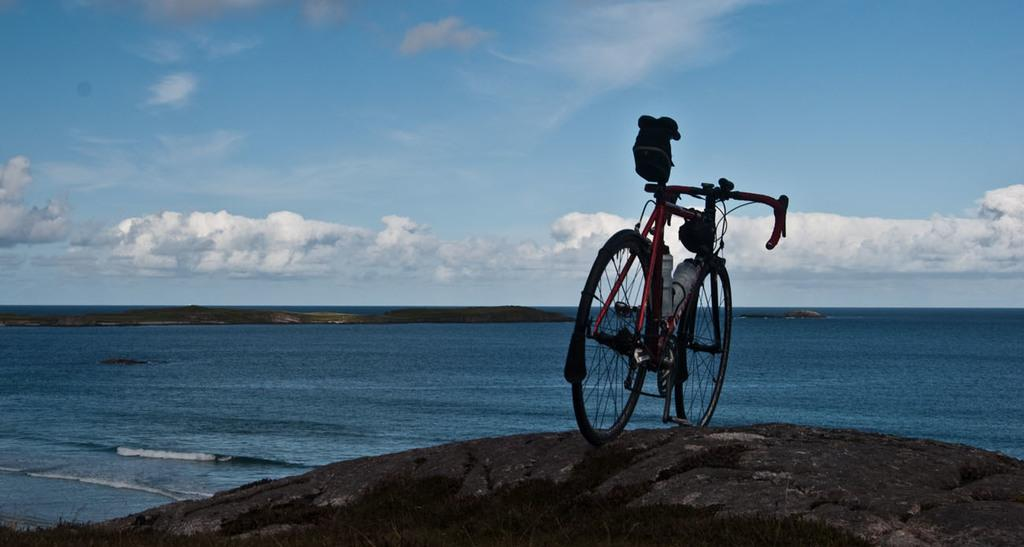What is the main object in the image? There is a bicycle in the image. Where is the bicycle located? The bicycle is on a rock surface. What is the surrounding environment like? The rock surface is near the sea, and there are rocks visible in the water. What color is the water in the image? The water in the image is blue. What can be seen in the sky? The sky is visible in the image, and there are clouds present. What is the price of the son's bicycle in the image? There is no son or price mentioned in the image; it only features a bicycle on a rock surface near the sea. 